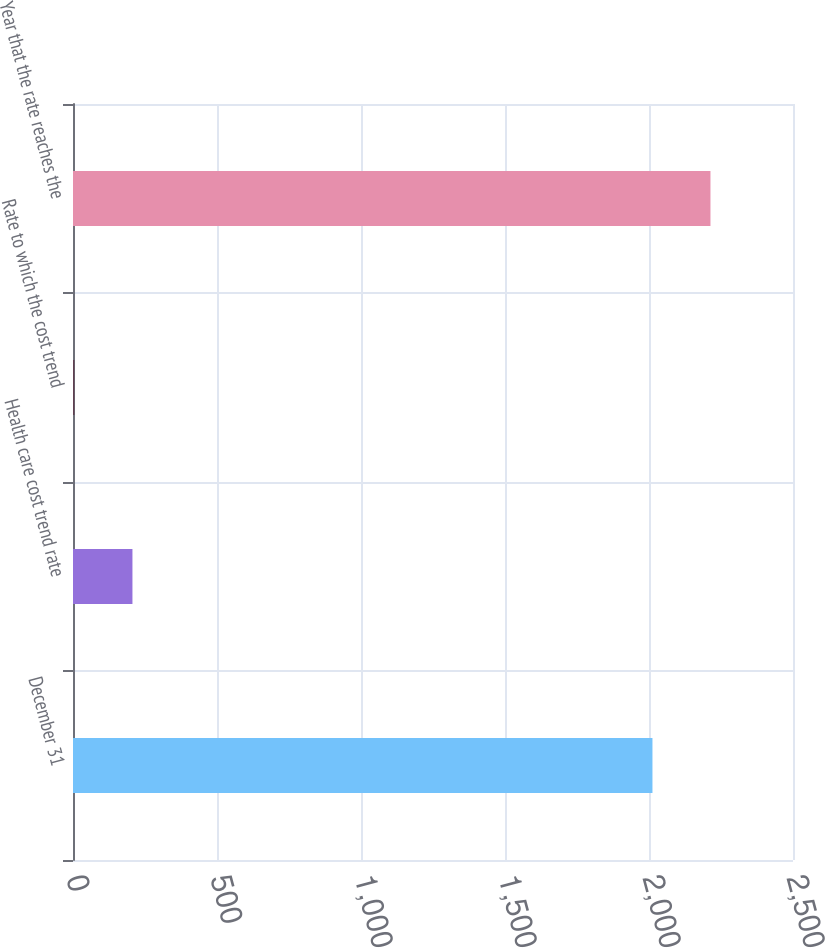Convert chart. <chart><loc_0><loc_0><loc_500><loc_500><bar_chart><fcel>December 31<fcel>Health care cost trend rate<fcel>Rate to which the cost trend<fcel>Year that the rate reaches the<nl><fcel>2012<fcel>206.4<fcel>5<fcel>2213.4<nl></chart> 